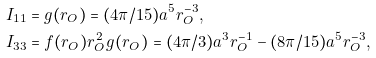Convert formula to latex. <formula><loc_0><loc_0><loc_500><loc_500>I _ { 1 1 } & = g ( r _ { O } ) = ( 4 \pi / 1 5 ) a ^ { 5 } r _ { O } ^ { - 3 } , \\ I _ { 3 3 } & = f ( r _ { O } ) r _ { O } ^ { 2 } g ( r _ { O } ) = ( 4 \pi / 3 ) a ^ { 3 } r _ { O } ^ { - 1 } - ( 8 \pi / 1 5 ) a ^ { 5 } r _ { O } ^ { - 3 } ,</formula> 